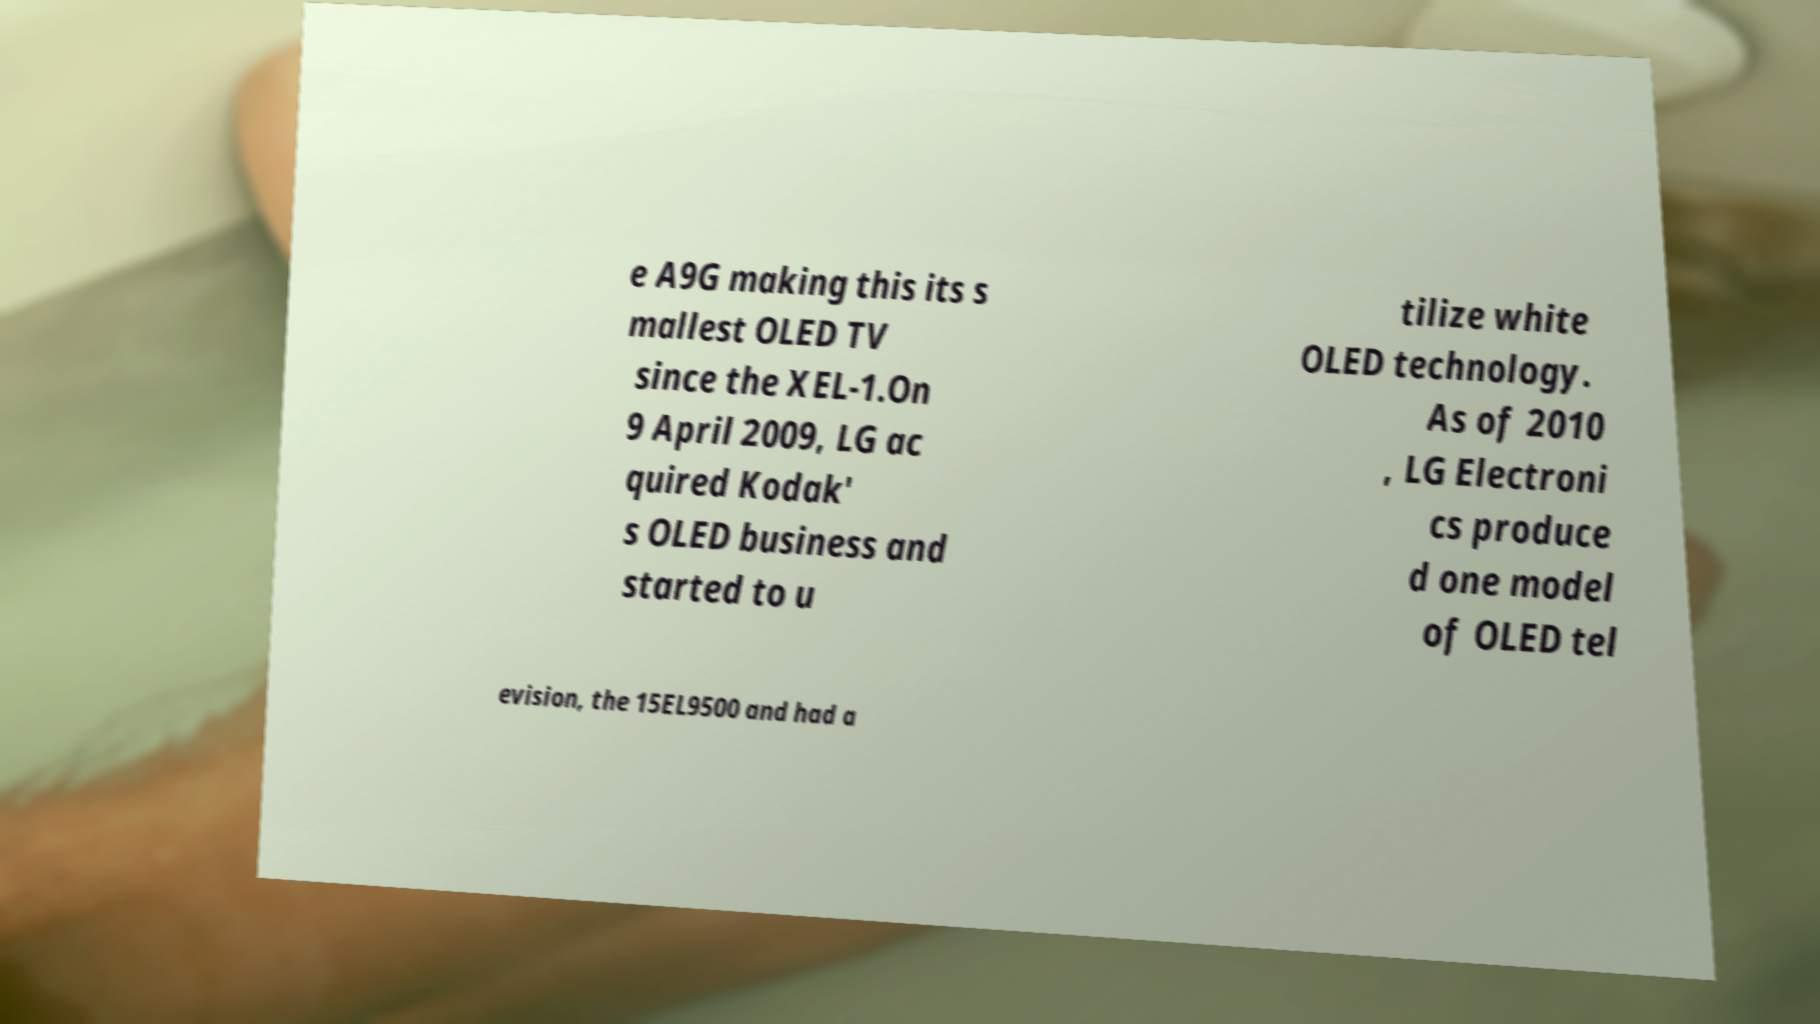Could you extract and type out the text from this image? e A9G making this its s mallest OLED TV since the XEL-1.On 9 April 2009, LG ac quired Kodak' s OLED business and started to u tilize white OLED technology. As of 2010 , LG Electroni cs produce d one model of OLED tel evision, the 15EL9500 and had a 